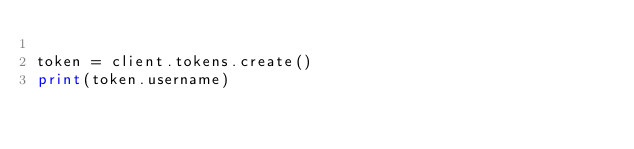<code> <loc_0><loc_0><loc_500><loc_500><_Python_>
token = client.tokens.create()
print(token.username)
</code> 